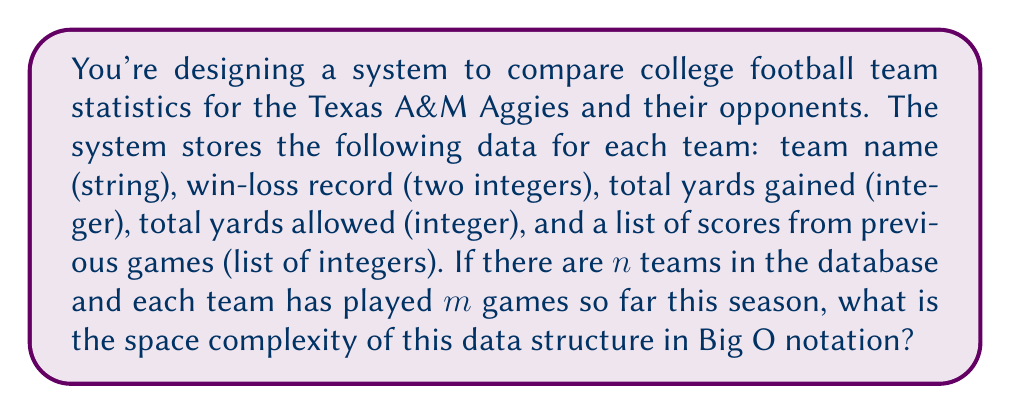Give your solution to this math problem. Let's break down the space requirements for each component of the data structure:

1. Team name: This is a string, which typically has a constant maximum length in practice. We can consider it $O(1)$ space per team.

2. Win-loss record: Two integers, which is $O(1)$ space per team.

3. Total yards gained: One integer, $O(1)$ space per team.

4. Total yards allowed: One integer, $O(1)$ space per team.

5. List of scores: This is where the variable component comes in. For each team, we store $m$ integers (one for each game played). This requires $O(m)$ space per team.

Now, we have $n$ teams in total, and for each team, we store $O(1) + O(1) + O(1) + O(1) + O(m) = O(m)$ space.

Therefore, for all $n$ teams, the total space complexity is:

$$O(n \cdot m)$$

This represents the worst-case scenario where we store all the data for all teams. In Big O notation, we always consider the worst-case scenario.

It's worth noting that in a real-world scenario, $m$ (the number of games played) would typically be much smaller than $n$ (the number of teams) and often has a fixed maximum (e.g., a regular season might have at most 12-14 games). If $m$ were considered a constant, the space complexity could be simplified to $O(n)$. However, for the purposes of this analysis, we'll treat $m$ as a variable.
Answer: $O(n \cdot m)$, where $n$ is the number of teams and $m$ is the number of games played per team. 